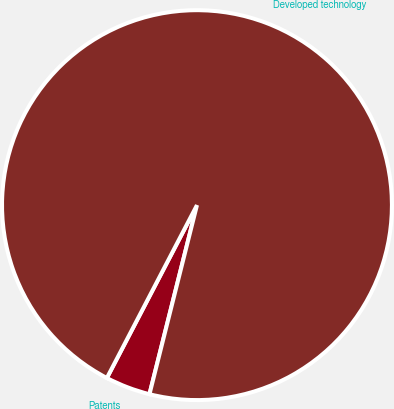Convert chart. <chart><loc_0><loc_0><loc_500><loc_500><pie_chart><fcel>Patents<fcel>Developed technology<nl><fcel>3.73%<fcel>96.27%<nl></chart> 